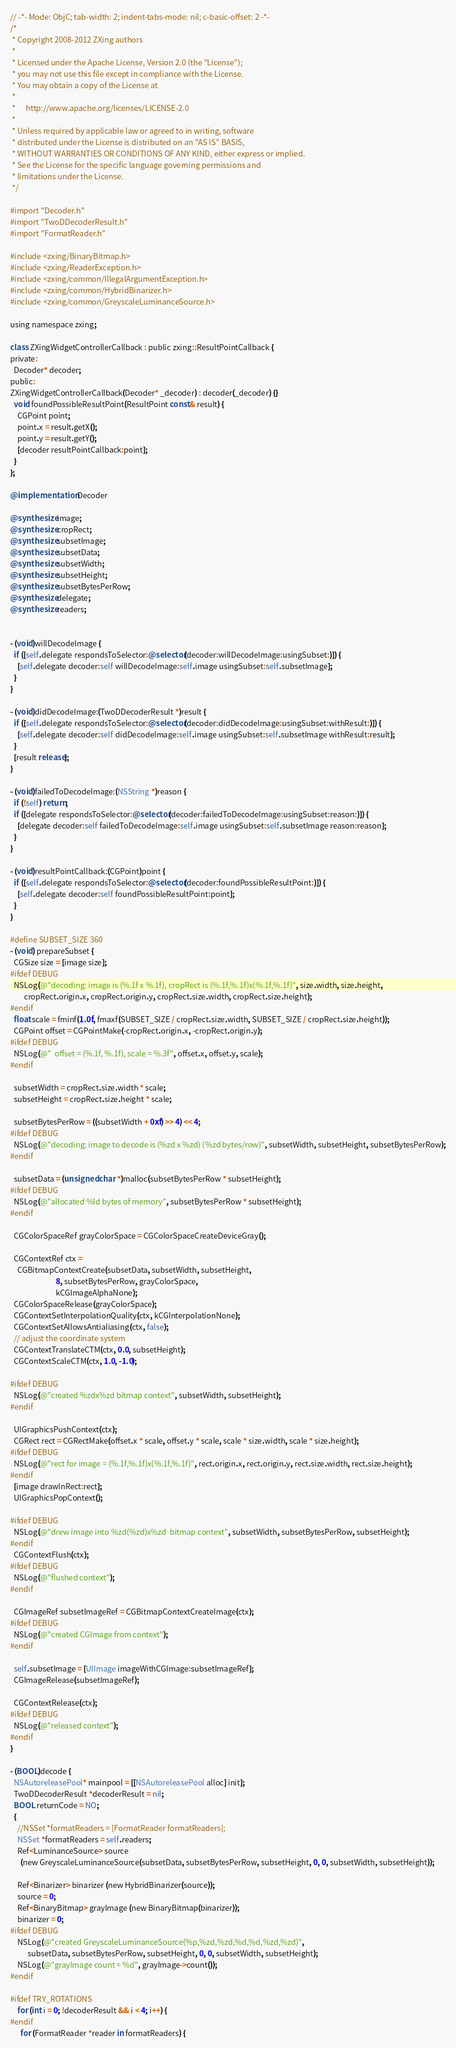<code> <loc_0><loc_0><loc_500><loc_500><_ObjectiveC_>// -*- Mode: ObjC; tab-width: 2; indent-tabs-mode: nil; c-basic-offset: 2 -*-
/*
 * Copyright 2008-2012 ZXing authors
 *
 * Licensed under the Apache License, Version 2.0 (the "License");
 * you may not use this file except in compliance with the License.
 * You may obtain a copy of the License at
 *
 *      http://www.apache.org/licenses/LICENSE-2.0
 *
 * Unless required by applicable law or agreed to in writing, software
 * distributed under the License is distributed on an "AS IS" BASIS,
 * WITHOUT WARRANTIES OR CONDITIONS OF ANY KIND, either express or implied.
 * See the License for the specific language governing permissions and
 * limitations under the License.
 */

#import "Decoder.h"
#import "TwoDDecoderResult.h"
#import "FormatReader.h"

#include <zxing/BinaryBitmap.h>
#include <zxing/ReaderException.h>
#include <zxing/common/IllegalArgumentException.h>
#include <zxing/common/HybridBinarizer.h>
#include <zxing/common/GreyscaleLuminanceSource.h>

using namespace zxing;

class ZXingWidgetControllerCallback : public zxing::ResultPointCallback {
private:
  Decoder* decoder;
public:
ZXingWidgetControllerCallback(Decoder* _decoder) : decoder(_decoder) {}
  void foundPossibleResultPoint(ResultPoint const& result) {
    CGPoint point;
    point.x = result.getX();
    point.y = result.getY();
    [decoder resultPointCallback:point];
  }
};

@implementation Decoder

@synthesize image;
@synthesize cropRect;
@synthesize subsetImage;
@synthesize subsetData;
@synthesize subsetWidth;
@synthesize subsetHeight;
@synthesize subsetBytesPerRow;
@synthesize delegate;
@synthesize readers;


- (void)willDecodeImage {
  if ([self.delegate respondsToSelector:@selector(decoder:willDecodeImage:usingSubset:)]) {
    [self.delegate decoder:self willDecodeImage:self.image usingSubset:self.subsetImage];
  }
}

- (void)didDecodeImage:(TwoDDecoderResult *)result {
  if ([self.delegate respondsToSelector:@selector(decoder:didDecodeImage:usingSubset:withResult:)]) {
    [self.delegate decoder:self didDecodeImage:self.image usingSubset:self.subsetImage withResult:result];
  }
  [result release];
}

- (void)failedToDecodeImage:(NSString *)reason {
  if (!self) return;
  if ([delegate respondsToSelector:@selector(decoder:failedToDecodeImage:usingSubset:reason:)]) {
    [delegate decoder:self failedToDecodeImage:self.image usingSubset:self.subsetImage reason:reason];
  }
}

- (void)resultPointCallback:(CGPoint)point {
  if ([self.delegate respondsToSelector:@selector(decoder:foundPossibleResultPoint:)]) {
    [self.delegate decoder:self foundPossibleResultPoint:point];
  }
}

#define SUBSET_SIZE 360
- (void) prepareSubset {
  CGSize size = [image size];
#ifdef DEBUG
  NSLog(@"decoding: image is (%.1f x %.1f), cropRect is (%.1f,%.1f)x(%.1f,%.1f)", size.width, size.height,
        cropRect.origin.x, cropRect.origin.y, cropRect.size.width, cropRect.size.height);
#endif
  float scale = fminf(1.0f, fmaxf(SUBSET_SIZE / cropRect.size.width, SUBSET_SIZE / cropRect.size.height));
  CGPoint offset = CGPointMake(-cropRect.origin.x, -cropRect.origin.y);
#ifdef DEBUG
  NSLog(@"  offset = (%.1f, %.1f), scale = %.3f", offset.x, offset.y, scale);
#endif
  
  subsetWidth = cropRect.size.width * scale;
  subsetHeight = cropRect.size.height * scale;
  
  subsetBytesPerRow = ((subsetWidth + 0xf) >> 4) << 4;
#ifdef DEBUG
  NSLog(@"decoding: image to decode is (%zd x %zd) (%zd bytes/row)", subsetWidth, subsetHeight, subsetBytesPerRow);
#endif
  
  subsetData = (unsigned char *)malloc(subsetBytesPerRow * subsetHeight);
#ifdef DEBUG
  NSLog(@"allocated %ld bytes of memory", subsetBytesPerRow * subsetHeight);
#endif
  
  CGColorSpaceRef grayColorSpace = CGColorSpaceCreateDeviceGray();
  
  CGContextRef ctx = 
    CGBitmapContextCreate(subsetData, subsetWidth, subsetHeight, 
                          8, subsetBytesPerRow, grayColorSpace, 
                          kCGImageAlphaNone);
  CGColorSpaceRelease(grayColorSpace);
  CGContextSetInterpolationQuality(ctx, kCGInterpolationNone);
  CGContextSetAllowsAntialiasing(ctx, false);
  // adjust the coordinate system
  CGContextTranslateCTM(ctx, 0.0, subsetHeight);
  CGContextScaleCTM(ctx, 1.0, -1.0);  
  
#ifdef DEBUG
  NSLog(@"created %zdx%zd bitmap context", subsetWidth, subsetHeight);
#endif
  
  UIGraphicsPushContext(ctx);
  CGRect rect = CGRectMake(offset.x * scale, offset.y * scale, scale * size.width, scale * size.height);
#ifdef DEBUG
  NSLog(@"rect for image = (%.1f,%.1f)x(%.1f,%.1f)", rect.origin.x, rect.origin.y, rect.size.width, rect.size.height);
#endif
  [image drawInRect:rect];
  UIGraphicsPopContext();
  
#ifdef DEBUG
  NSLog(@"drew image into %zd(%zd)x%zd  bitmap context", subsetWidth, subsetBytesPerRow, subsetHeight);
#endif
  CGContextFlush(ctx);
#ifdef DEBUG
  NSLog(@"flushed context");
#endif
    
  CGImageRef subsetImageRef = CGBitmapContextCreateImage(ctx);
#ifdef DEBUG
  NSLog(@"created CGImage from context");
#endif
  
  self.subsetImage = [UIImage imageWithCGImage:subsetImageRef];
  CGImageRelease(subsetImageRef);
  
  CGContextRelease(ctx);
#ifdef DEBUG
  NSLog(@"released context");  
#endif
}  

- (BOOL)decode {
  NSAutoreleasePool* mainpool = [[NSAutoreleasePool alloc] init];
  TwoDDecoderResult *decoderResult = nil;
  BOOL returnCode = NO;
  { 
    //NSSet *formatReaders = [FormatReader formatReaders];
    NSSet *formatReaders = self.readers;
    Ref<LuminanceSource> source 
      (new GreyscaleLuminanceSource(subsetData, subsetBytesPerRow, subsetHeight, 0, 0, subsetWidth, subsetHeight));

    Ref<Binarizer> binarizer (new HybridBinarizer(source));
    source = 0;
    Ref<BinaryBitmap> grayImage (new BinaryBitmap(binarizer));
    binarizer = 0;
#ifdef DEBUG
    NSLog(@"created GreyscaleLuminanceSource(%p,%zd,%zd,%d,%d,%zd,%zd)",
          subsetData, subsetBytesPerRow, subsetHeight, 0, 0, subsetWidth, subsetHeight);
    NSLog(@"grayImage count = %d", grayImage->count());
#endif
    
#ifdef TRY_ROTATIONS
    for (int i = 0; !decoderResult && i < 4; i++) {
#endif
      for (FormatReader *reader in formatReaders) {</code> 